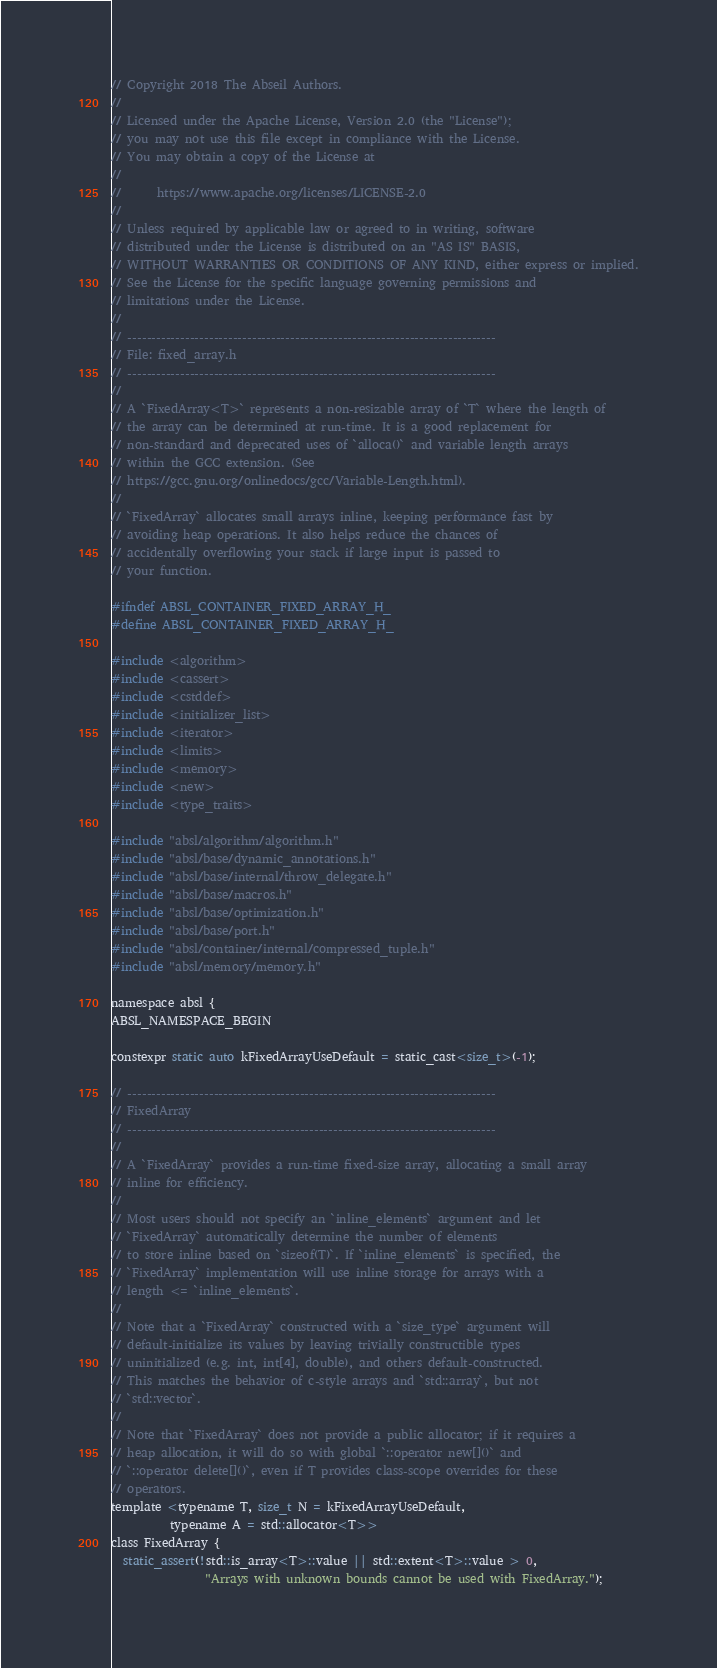Convert code to text. <code><loc_0><loc_0><loc_500><loc_500><_C_>// Copyright 2018 The Abseil Authors.
//
// Licensed under the Apache License, Version 2.0 (the "License");
// you may not use this file except in compliance with the License.
// You may obtain a copy of the License at
//
//      https://www.apache.org/licenses/LICENSE-2.0
//
// Unless required by applicable law or agreed to in writing, software
// distributed under the License is distributed on an "AS IS" BASIS,
// WITHOUT WARRANTIES OR CONDITIONS OF ANY KIND, either express or implied.
// See the License for the specific language governing permissions and
// limitations under the License.
//
// -----------------------------------------------------------------------------
// File: fixed_array.h
// -----------------------------------------------------------------------------
//
// A `FixedArray<T>` represents a non-resizable array of `T` where the length of
// the array can be determined at run-time. It is a good replacement for
// non-standard and deprecated uses of `alloca()` and variable length arrays
// within the GCC extension. (See
// https://gcc.gnu.org/onlinedocs/gcc/Variable-Length.html).
//
// `FixedArray` allocates small arrays inline, keeping performance fast by
// avoiding heap operations. It also helps reduce the chances of
// accidentally overflowing your stack if large input is passed to
// your function.

#ifndef ABSL_CONTAINER_FIXED_ARRAY_H_
#define ABSL_CONTAINER_FIXED_ARRAY_H_

#include <algorithm>
#include <cassert>
#include <cstddef>
#include <initializer_list>
#include <iterator>
#include <limits>
#include <memory>
#include <new>
#include <type_traits>

#include "absl/algorithm/algorithm.h"
#include "absl/base/dynamic_annotations.h"
#include "absl/base/internal/throw_delegate.h"
#include "absl/base/macros.h"
#include "absl/base/optimization.h"
#include "absl/base/port.h"
#include "absl/container/internal/compressed_tuple.h"
#include "absl/memory/memory.h"

namespace absl {
ABSL_NAMESPACE_BEGIN

constexpr static auto kFixedArrayUseDefault = static_cast<size_t>(-1);

// -----------------------------------------------------------------------------
// FixedArray
// -----------------------------------------------------------------------------
//
// A `FixedArray` provides a run-time fixed-size array, allocating a small array
// inline for efficiency.
//
// Most users should not specify an `inline_elements` argument and let
// `FixedArray` automatically determine the number of elements
// to store inline based on `sizeof(T)`. If `inline_elements` is specified, the
// `FixedArray` implementation will use inline storage for arrays with a
// length <= `inline_elements`.
//
// Note that a `FixedArray` constructed with a `size_type` argument will
// default-initialize its values by leaving trivially constructible types
// uninitialized (e.g. int, int[4], double), and others default-constructed.
// This matches the behavior of c-style arrays and `std::array`, but not
// `std::vector`.
//
// Note that `FixedArray` does not provide a public allocator; if it requires a
// heap allocation, it will do so with global `::operator new[]()` and
// `::operator delete[]()`, even if T provides class-scope overrides for these
// operators.
template <typename T, size_t N = kFixedArrayUseDefault,
          typename A = std::allocator<T>>
class FixedArray {
  static_assert(!std::is_array<T>::value || std::extent<T>::value > 0,
                "Arrays with unknown bounds cannot be used with FixedArray.");
</code> 